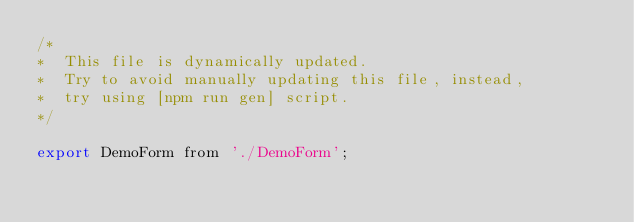Convert code to text. <code><loc_0><loc_0><loc_500><loc_500><_JavaScript_>/*
*  This file is dynamically updated.
*  Try to avoid manually updating this file, instead,
*  try using [npm run gen] script.
*/

export DemoForm from './DemoForm';
</code> 